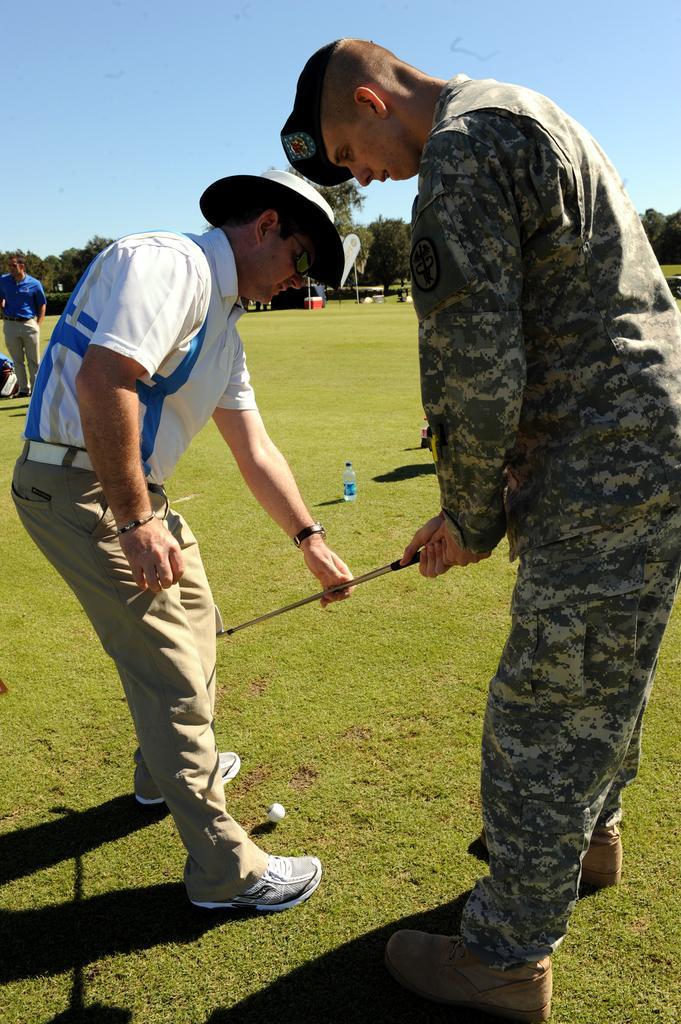Please provide a concise description of this image. In this image, we can see two persons wearing clothes and holding a stick with their hands. There is a golf ball at the bottom of the image. There is an another person on the left side of the image standing and wearing clothes. There are some trees in the middle of the image. At the top of the image, we can see the sky. 